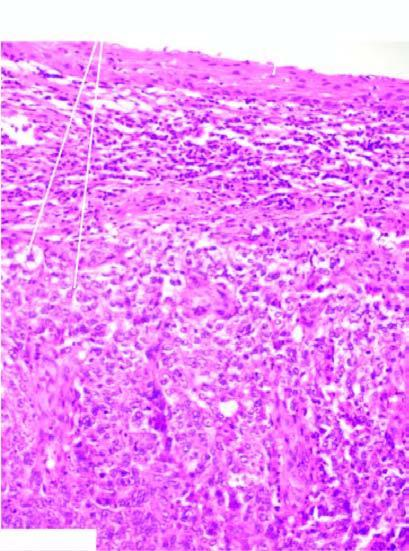what is composed of undifferentiated anaplastic cells arranged in nests?
Answer the question using a single word or phrase. Tumour 